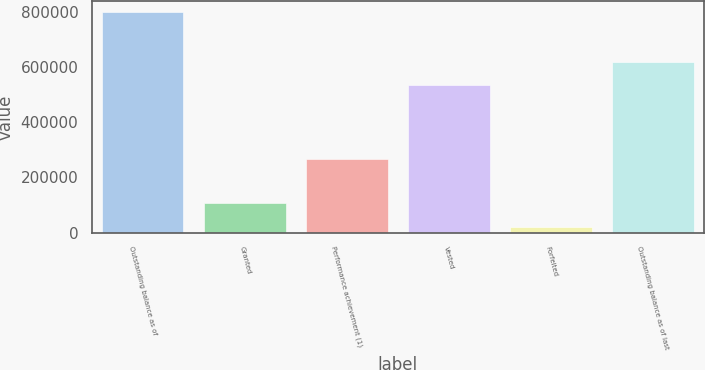Convert chart. <chart><loc_0><loc_0><loc_500><loc_500><bar_chart><fcel>Outstanding balance as of<fcel>Granted<fcel>Performance achievement (1)<fcel>Vested<fcel>Forfeited<fcel>Outstanding balance as of last<nl><fcel>798600<fcel>108290<fcel>268260<fcel>536520<fcel>20946<fcel>617684<nl></chart> 